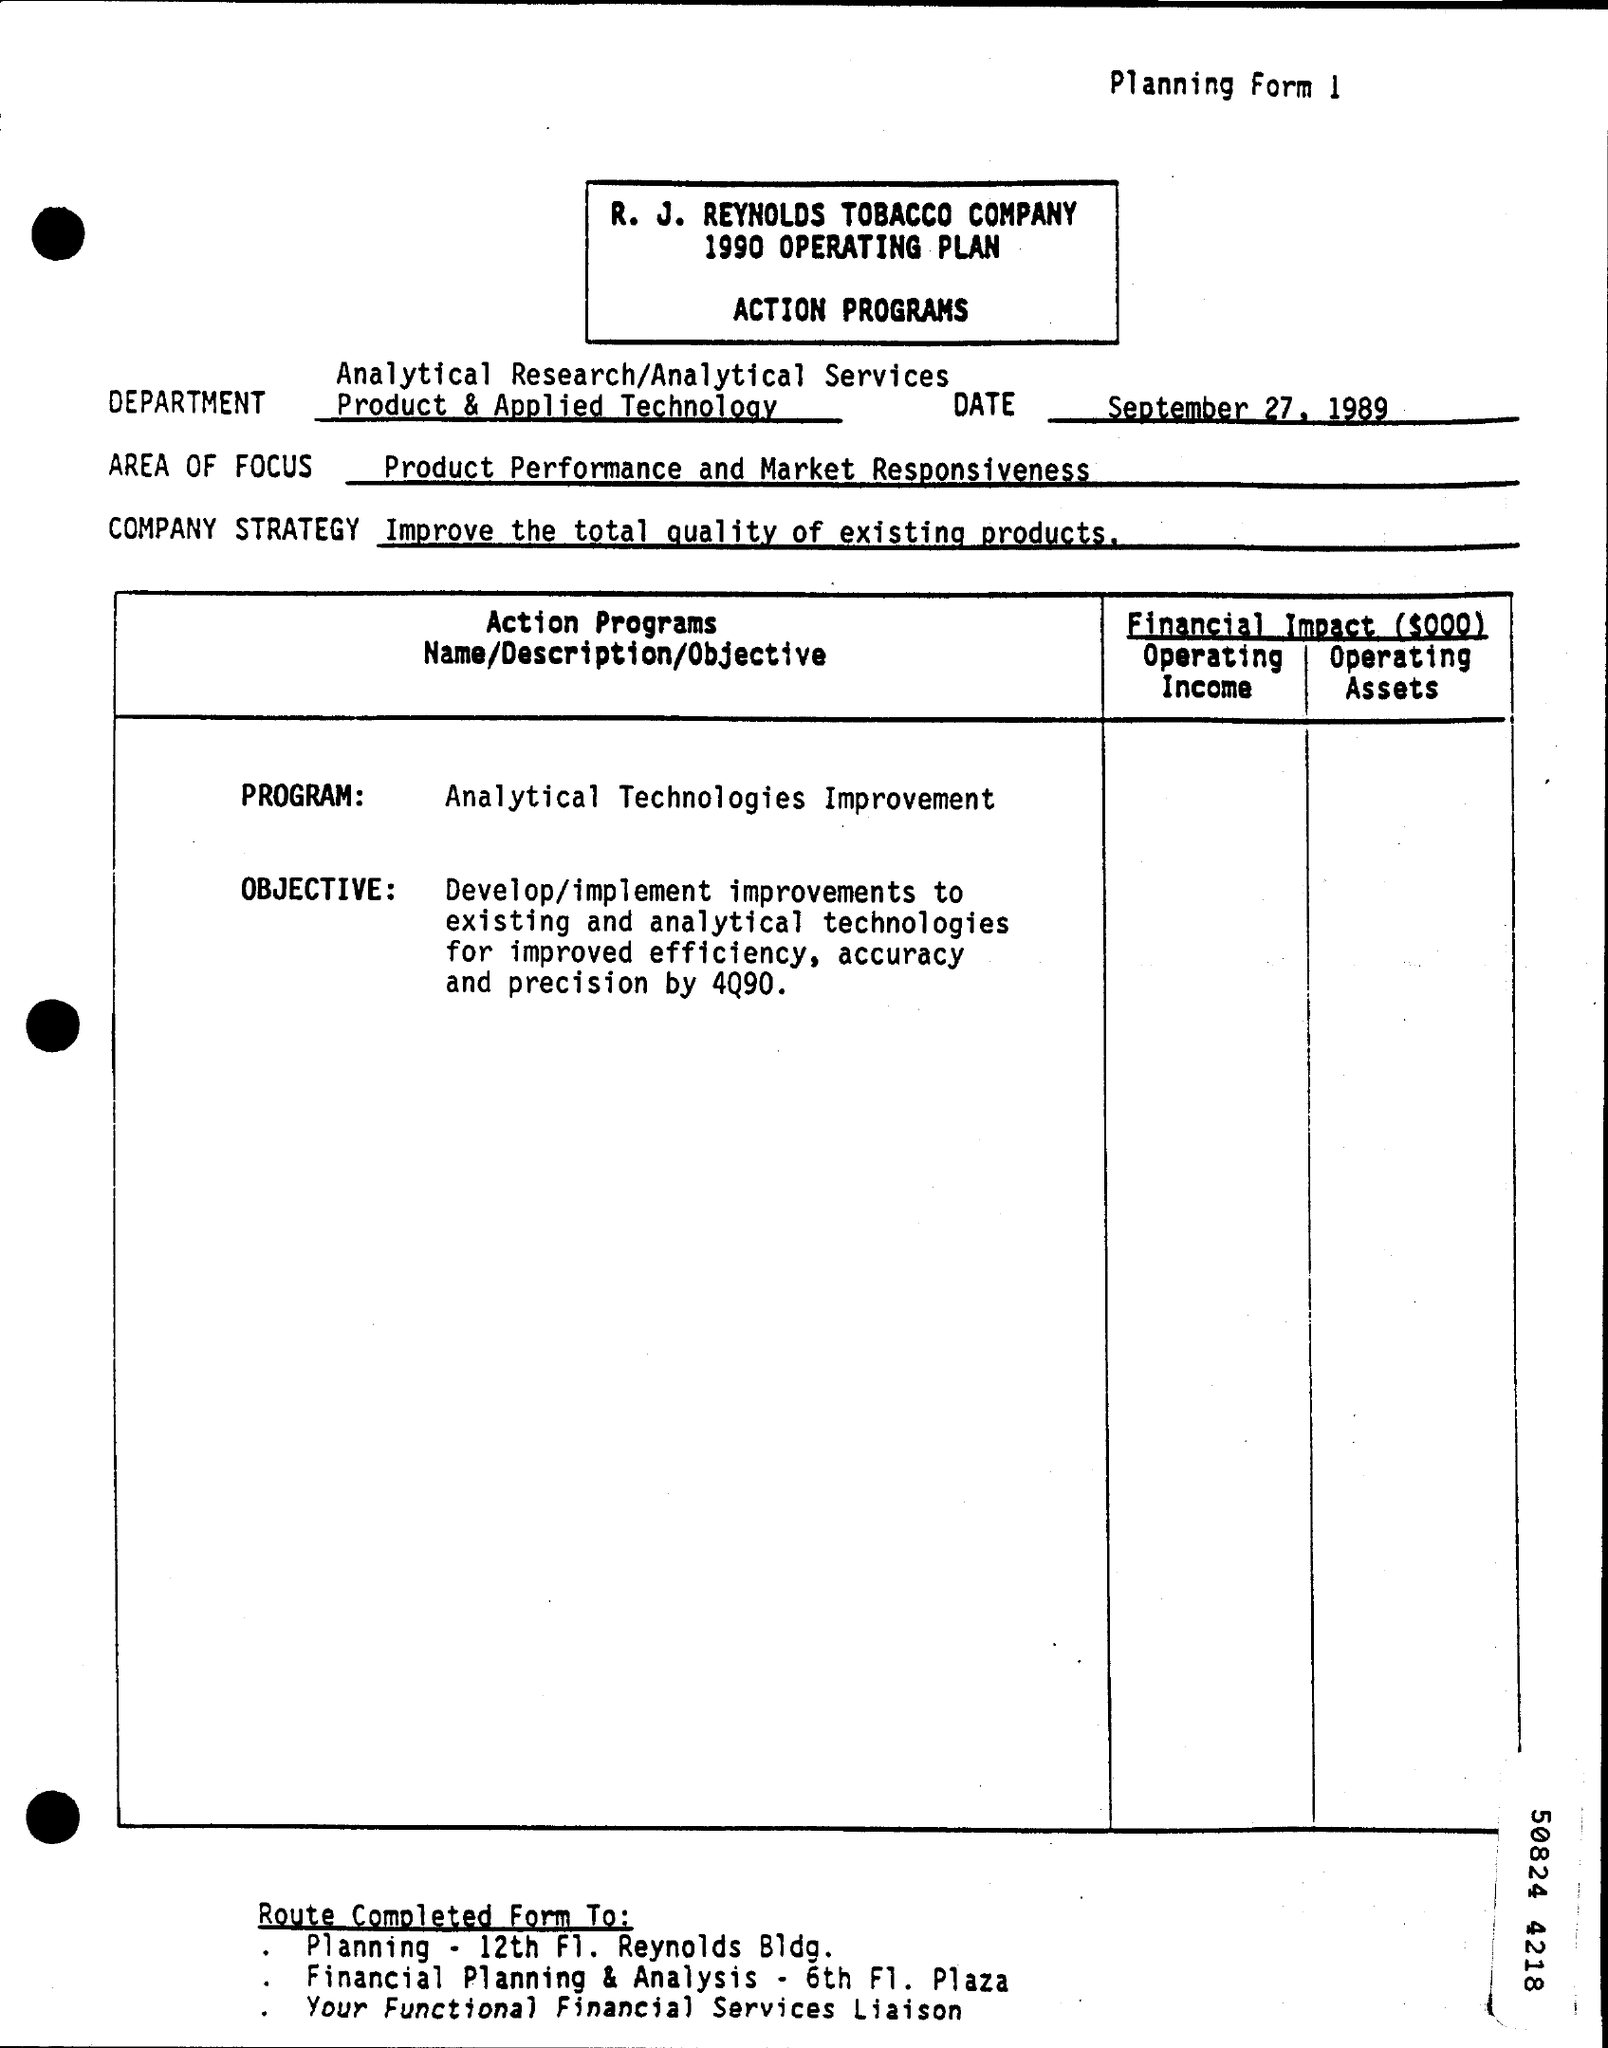What is the Number for Planning Form ?
Keep it short and to the point. 1. When is the Memorandum dated on ?
Your answer should be very brief. SEPTEMBER 27, 1989. What is the Company Strategy ?
Ensure brevity in your answer.  Improve the total quality of existing products. What is written in the Program Field ?
Provide a succinct answer. Analytical Technologies Improvement. What is written in the AREA OF FOCUS Field ?
Offer a terse response. Product Performance and Market Responsiveness. 